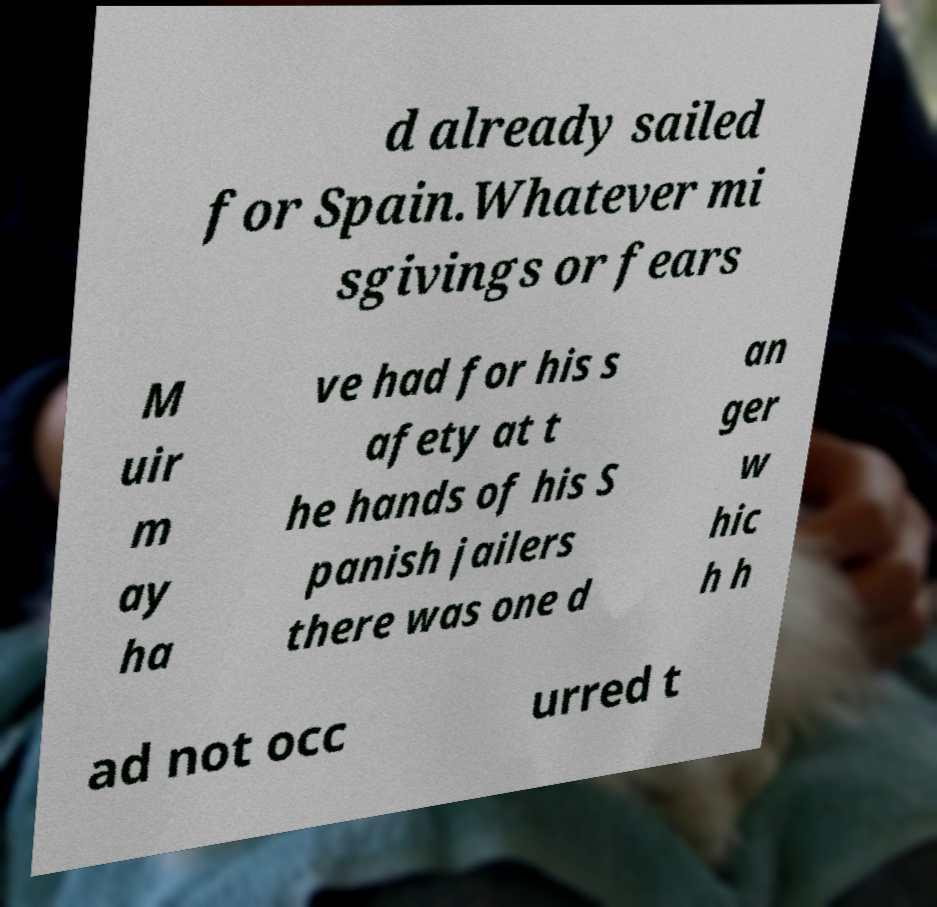Please identify and transcribe the text found in this image. d already sailed for Spain.Whatever mi sgivings or fears M uir m ay ha ve had for his s afety at t he hands of his S panish jailers there was one d an ger w hic h h ad not occ urred t 